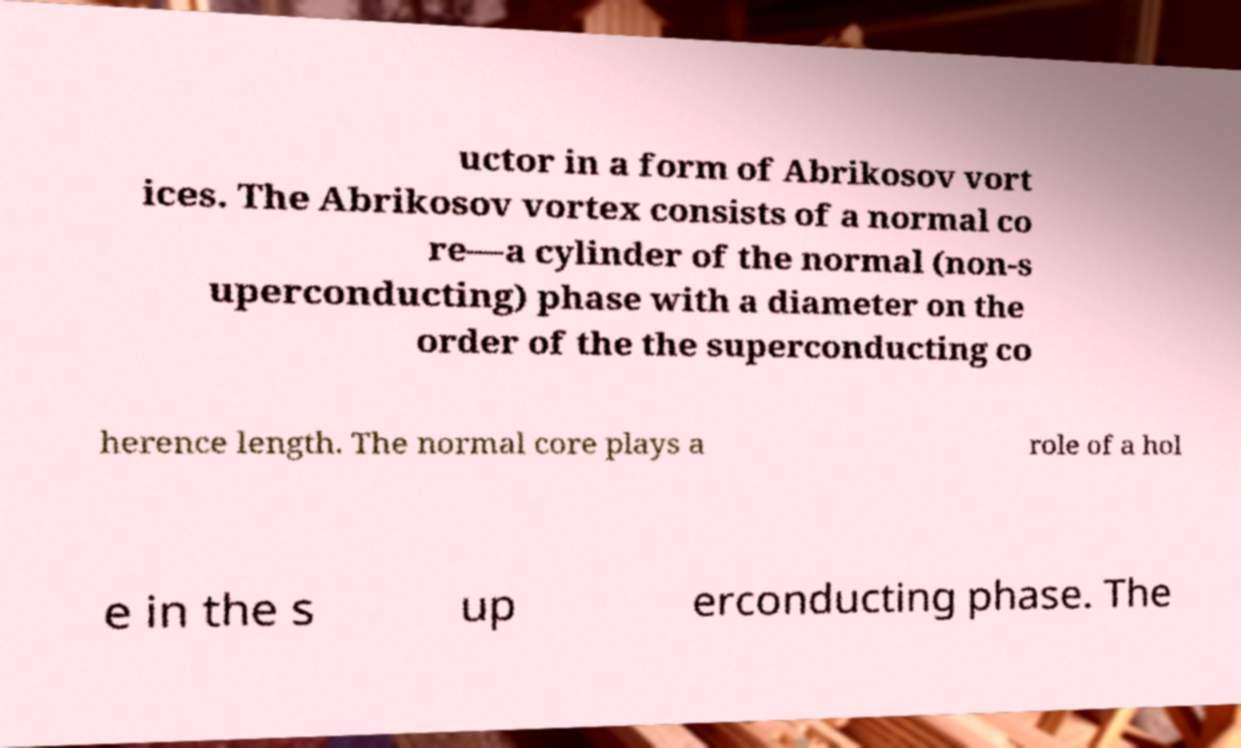Please read and relay the text visible in this image. What does it say? uctor in a form of Abrikosov vort ices. The Abrikosov vortex consists of a normal co re—a cylinder of the normal (non-s uperconducting) phase with a diameter on the order of the the superconducting co herence length. The normal core plays a role of a hol e in the s up erconducting phase. The 